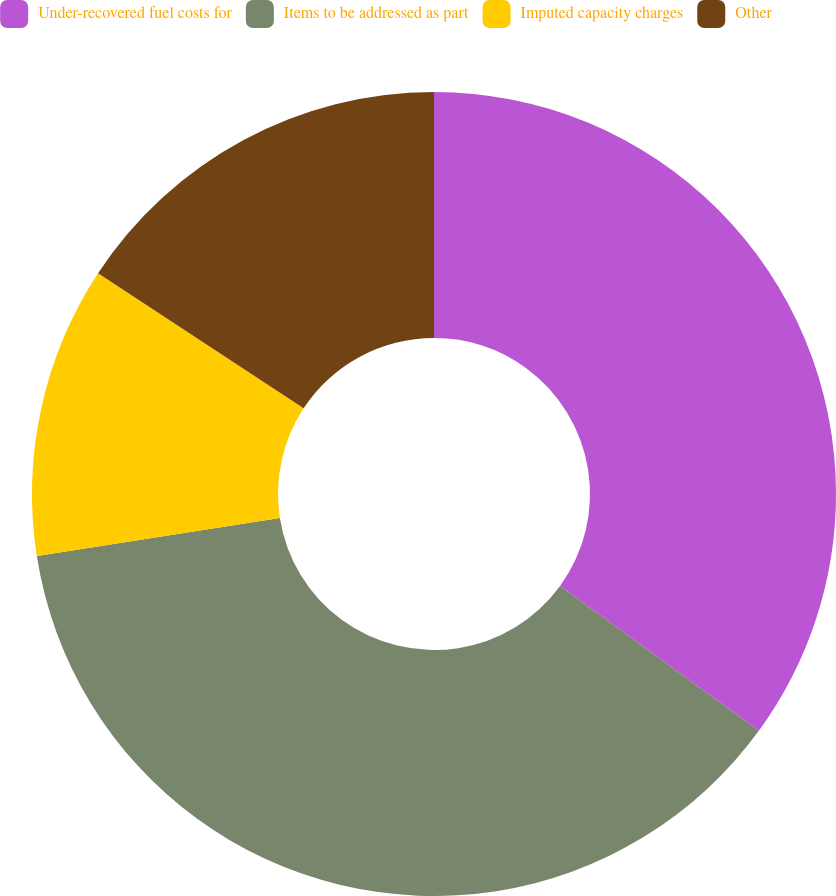<chart> <loc_0><loc_0><loc_500><loc_500><pie_chart><fcel>Under-recovered fuel costs for<fcel>Items to be addressed as part<fcel>Imputed capacity charges<fcel>Other<nl><fcel>35.03%<fcel>37.51%<fcel>11.72%<fcel>15.75%<nl></chart> 